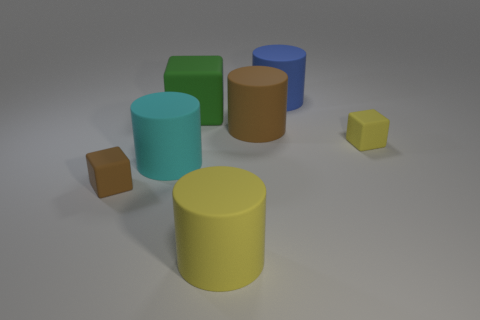Add 2 large shiny balls. How many objects exist? 9 Subtract all cylinders. How many objects are left? 3 Subtract all red shiny cylinders. Subtract all cyan things. How many objects are left? 6 Add 4 big blue objects. How many big blue objects are left? 5 Add 2 big brown objects. How many big brown objects exist? 3 Subtract 0 red cylinders. How many objects are left? 7 